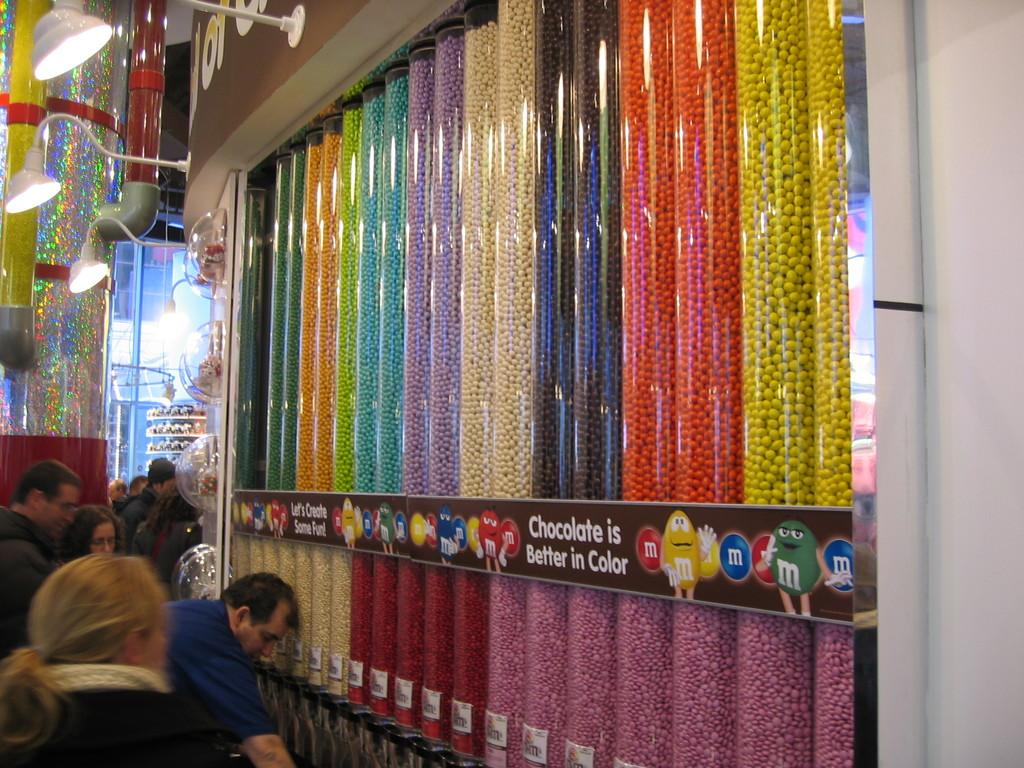<image>
Share a concise interpretation of the image provided. a candy store with tubes of m&ms labeled 'chocolate is better in color' 